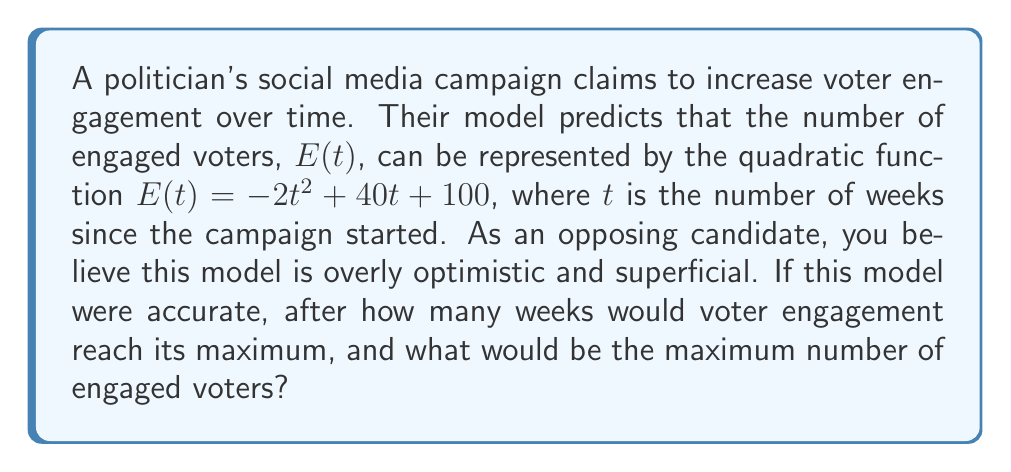Provide a solution to this math problem. To solve this problem, we need to analyze the quadratic function given:

$E(t) = -2t^2 + 40t + 100$

1) The general form of a quadratic function is $f(x) = ax^2 + bx + c$, where $a \neq 0$.
   In this case, $a = -2$, $b = 40$, and $c = 100$.

2) For a quadratic function, the vertex represents the maximum (when $a < 0$) or minimum (when $a > 0$) point.

3) To find the t-coordinate of the vertex (which represents the number of weeks until maximum engagement), we use the formula:

   $t = -\frac{b}{2a}$

4) Substituting the values:
   $t = -\frac{40}{2(-2)} = -\frac{40}{-4} = 10$

5) To find the maximum number of engaged voters, we substitute $t = 10$ into the original function:

   $E(10) = -2(10)^2 + 40(10) + 100$
          $= -2(100) + 400 + 100$
          $= -200 + 400 + 100$
          $= 300$

Therefore, according to this model, voter engagement would reach its maximum after 10 weeks, with 300 engaged voters.

As an opposing candidate, you might point out that this model unrealistically assumes a perfect parabolic trend and doesn't account for external factors or the complexity of voter behavior.
Answer: Maximum engagement occurs after 10 weeks, with 300 engaged voters. 